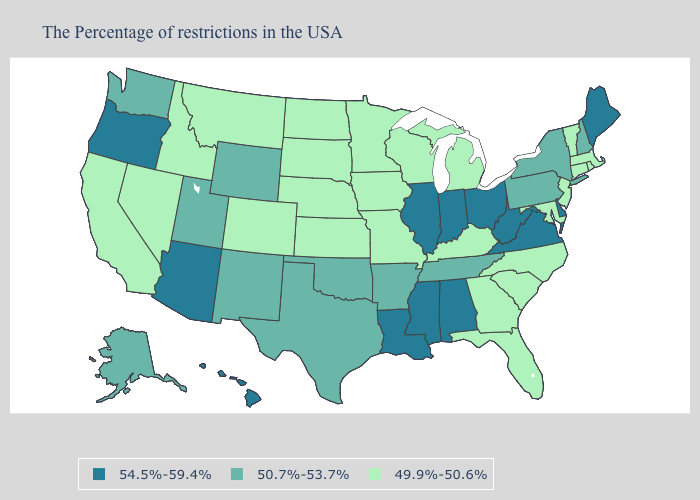How many symbols are there in the legend?
Give a very brief answer. 3. What is the lowest value in the West?
Quick response, please. 49.9%-50.6%. Among the states that border Kentucky , does Ohio have the highest value?
Answer briefly. Yes. Does the first symbol in the legend represent the smallest category?
Write a very short answer. No. Which states have the lowest value in the MidWest?
Write a very short answer. Michigan, Wisconsin, Missouri, Minnesota, Iowa, Kansas, Nebraska, South Dakota, North Dakota. Does Kentucky have a higher value than North Dakota?
Concise answer only. No. What is the value of Rhode Island?
Quick response, please. 49.9%-50.6%. What is the value of New York?
Keep it brief. 50.7%-53.7%. What is the value of New York?
Be succinct. 50.7%-53.7%. Which states have the lowest value in the USA?
Quick response, please. Massachusetts, Rhode Island, Vermont, Connecticut, New Jersey, Maryland, North Carolina, South Carolina, Florida, Georgia, Michigan, Kentucky, Wisconsin, Missouri, Minnesota, Iowa, Kansas, Nebraska, South Dakota, North Dakota, Colorado, Montana, Idaho, Nevada, California. Name the states that have a value in the range 49.9%-50.6%?
Be succinct. Massachusetts, Rhode Island, Vermont, Connecticut, New Jersey, Maryland, North Carolina, South Carolina, Florida, Georgia, Michigan, Kentucky, Wisconsin, Missouri, Minnesota, Iowa, Kansas, Nebraska, South Dakota, North Dakota, Colorado, Montana, Idaho, Nevada, California. What is the value of Michigan?
Give a very brief answer. 49.9%-50.6%. Does Wisconsin have the lowest value in the USA?
Short answer required. Yes. Name the states that have a value in the range 49.9%-50.6%?
Answer briefly. Massachusetts, Rhode Island, Vermont, Connecticut, New Jersey, Maryland, North Carolina, South Carolina, Florida, Georgia, Michigan, Kentucky, Wisconsin, Missouri, Minnesota, Iowa, Kansas, Nebraska, South Dakota, North Dakota, Colorado, Montana, Idaho, Nevada, California. What is the highest value in the Northeast ?
Answer briefly. 54.5%-59.4%. 